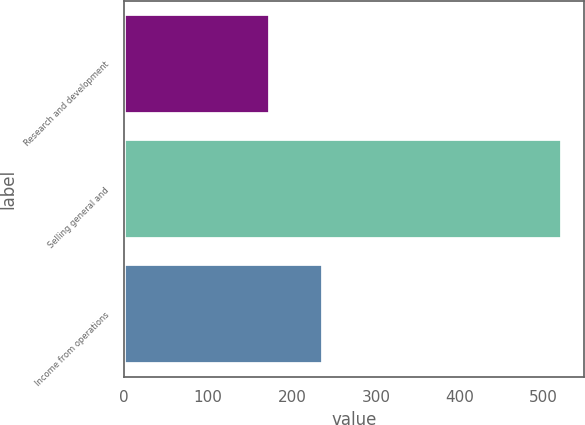Convert chart. <chart><loc_0><loc_0><loc_500><loc_500><bar_chart><fcel>Research and development<fcel>Selling general and<fcel>Income from operations<nl><fcel>174<fcel>522<fcel>237<nl></chart> 